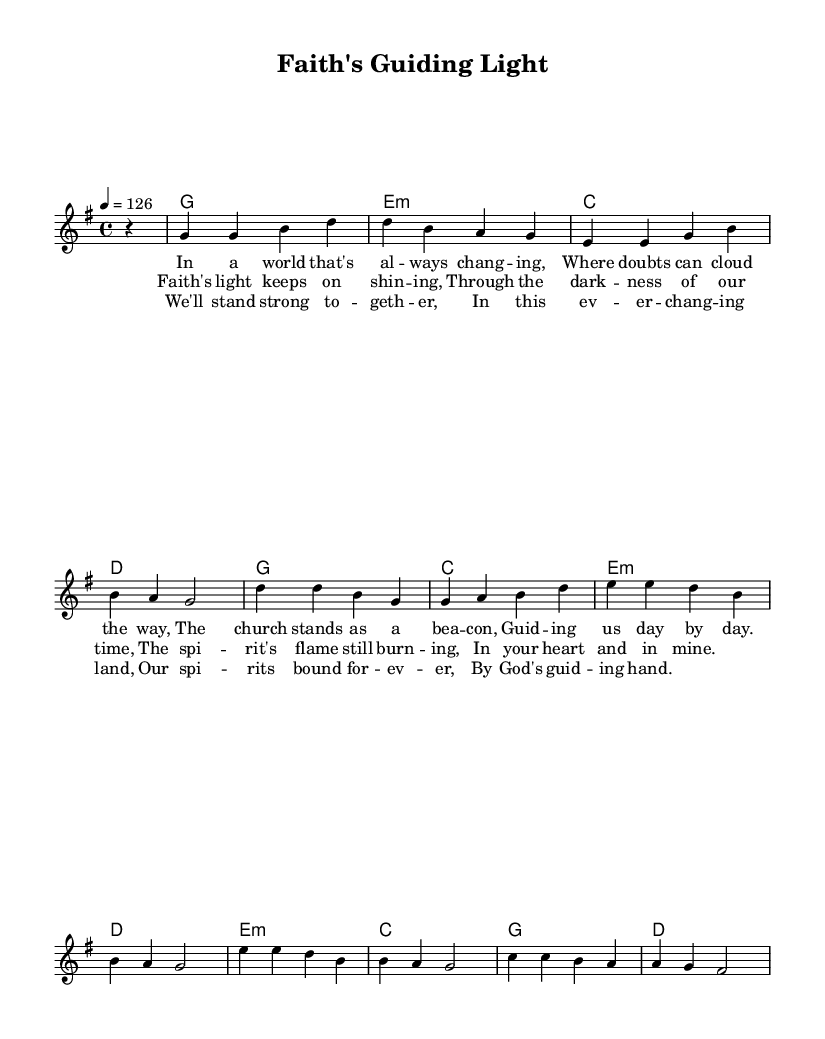What is the time signature of this music? The time signature is indicated by the notation "4/4" at the beginning of the piece, which means there are four beats in a measure and a quarter note receives one beat.
Answer: 4/4 What is the key signature of this music? The key signature is indicated by the notation "g major," which means the piece is in G major and typically includes one sharp (F#).
Answer: G major What is the tempo marking for this piece? The tempo marking is shown as "4 = 126," indicating that there are 126 beats per minute at a quarter note.
Answer: 126 How many lines of lyrics are in the verse? The verse contains four distinct lines of lyrics as shown in the lyric mode, each representing a separate phrase of the verse.
Answer: 4 What is the main theme expressed in the chorus? The chorus emphasizes the theme of spirituality and faith that provides guidance and light through difficult times, highlighted by the lyrics.
Answer: Spiritual guidance Which chord comes after the A major chord in the harmony? The chord progression can be traced from the harmony section, where the A major chord is followed by the D major chord.
Answer: D What does the bridge reveal about the community aspect of faith? The bridge lyrics speak to unity and strength in togetherness within a changing world, showcasing the importance of community in faith.
Answer: Unity and strength 